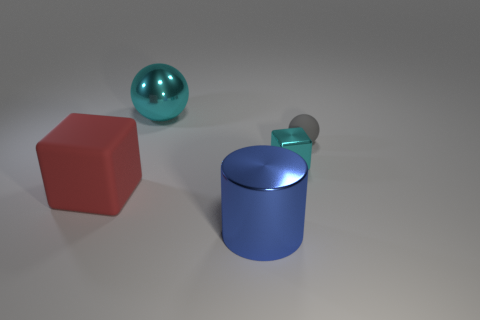Add 3 brown shiny cylinders. How many objects exist? 8 Subtract all cubes. How many objects are left? 3 Add 4 cyan shiny things. How many cyan shiny things exist? 6 Subtract 1 blue cylinders. How many objects are left? 4 Subtract all brown objects. Subtract all cyan metal things. How many objects are left? 3 Add 5 blue shiny objects. How many blue shiny objects are left? 6 